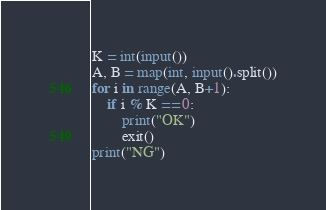<code> <loc_0><loc_0><loc_500><loc_500><_Python_>K = int(input())
A, B = map(int, input().split())
for i in range(A, B+1):
    if i % K == 0:
        print("OK")
        exit()
print("NG")
</code> 